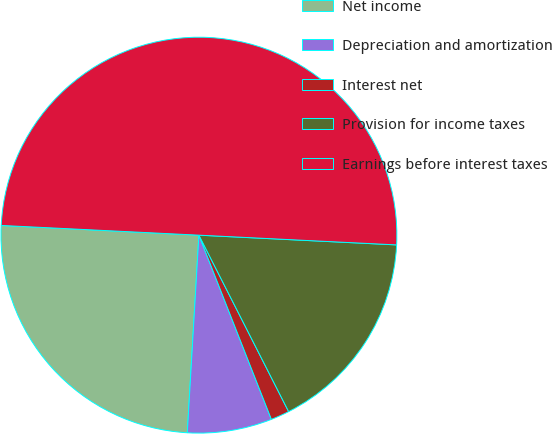Convert chart. <chart><loc_0><loc_0><loc_500><loc_500><pie_chart><fcel>Net income<fcel>Depreciation and amortization<fcel>Interest net<fcel>Provision for income taxes<fcel>Earnings before interest taxes<nl><fcel>24.85%<fcel>6.9%<fcel>1.52%<fcel>16.73%<fcel>50.0%<nl></chart> 